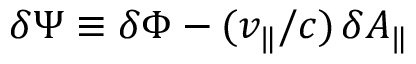<formula> <loc_0><loc_0><loc_500><loc_500>\delta \Psi \equiv \delta \Phi - ( v _ { \| } / c ) \, \delta A _ { \| }</formula> 